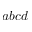Convert formula to latex. <formula><loc_0><loc_0><loc_500><loc_500>a b c d</formula> 